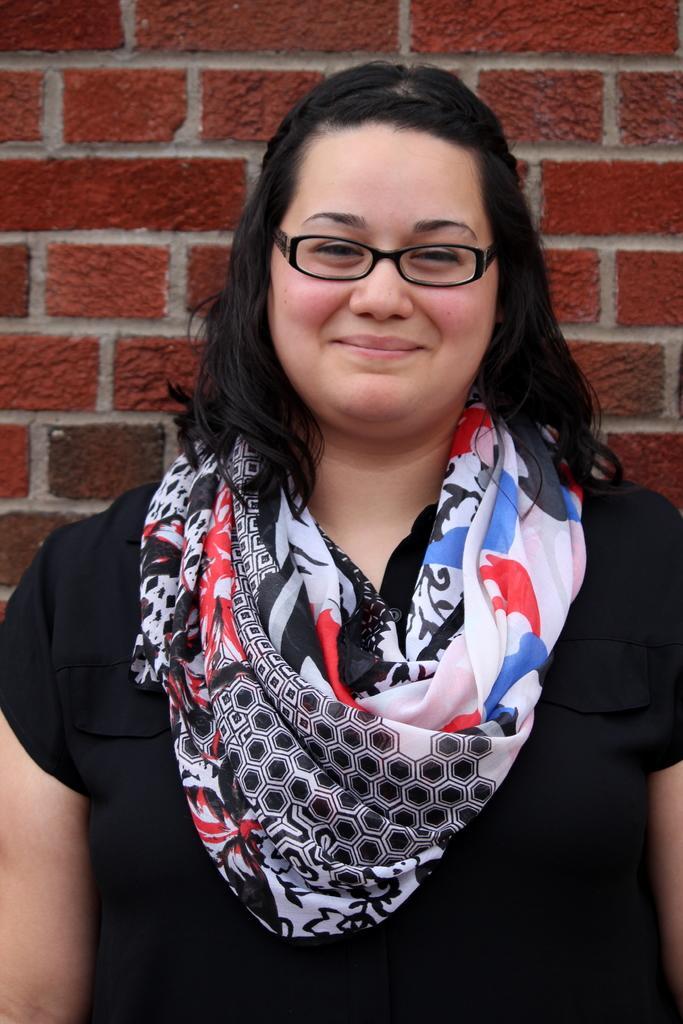Describe this image in one or two sentences. In the picture we can see a woman standing a she is smiling and wearing a black T-shirt and behind her we can see a wall with a painting of red color brick wall. 